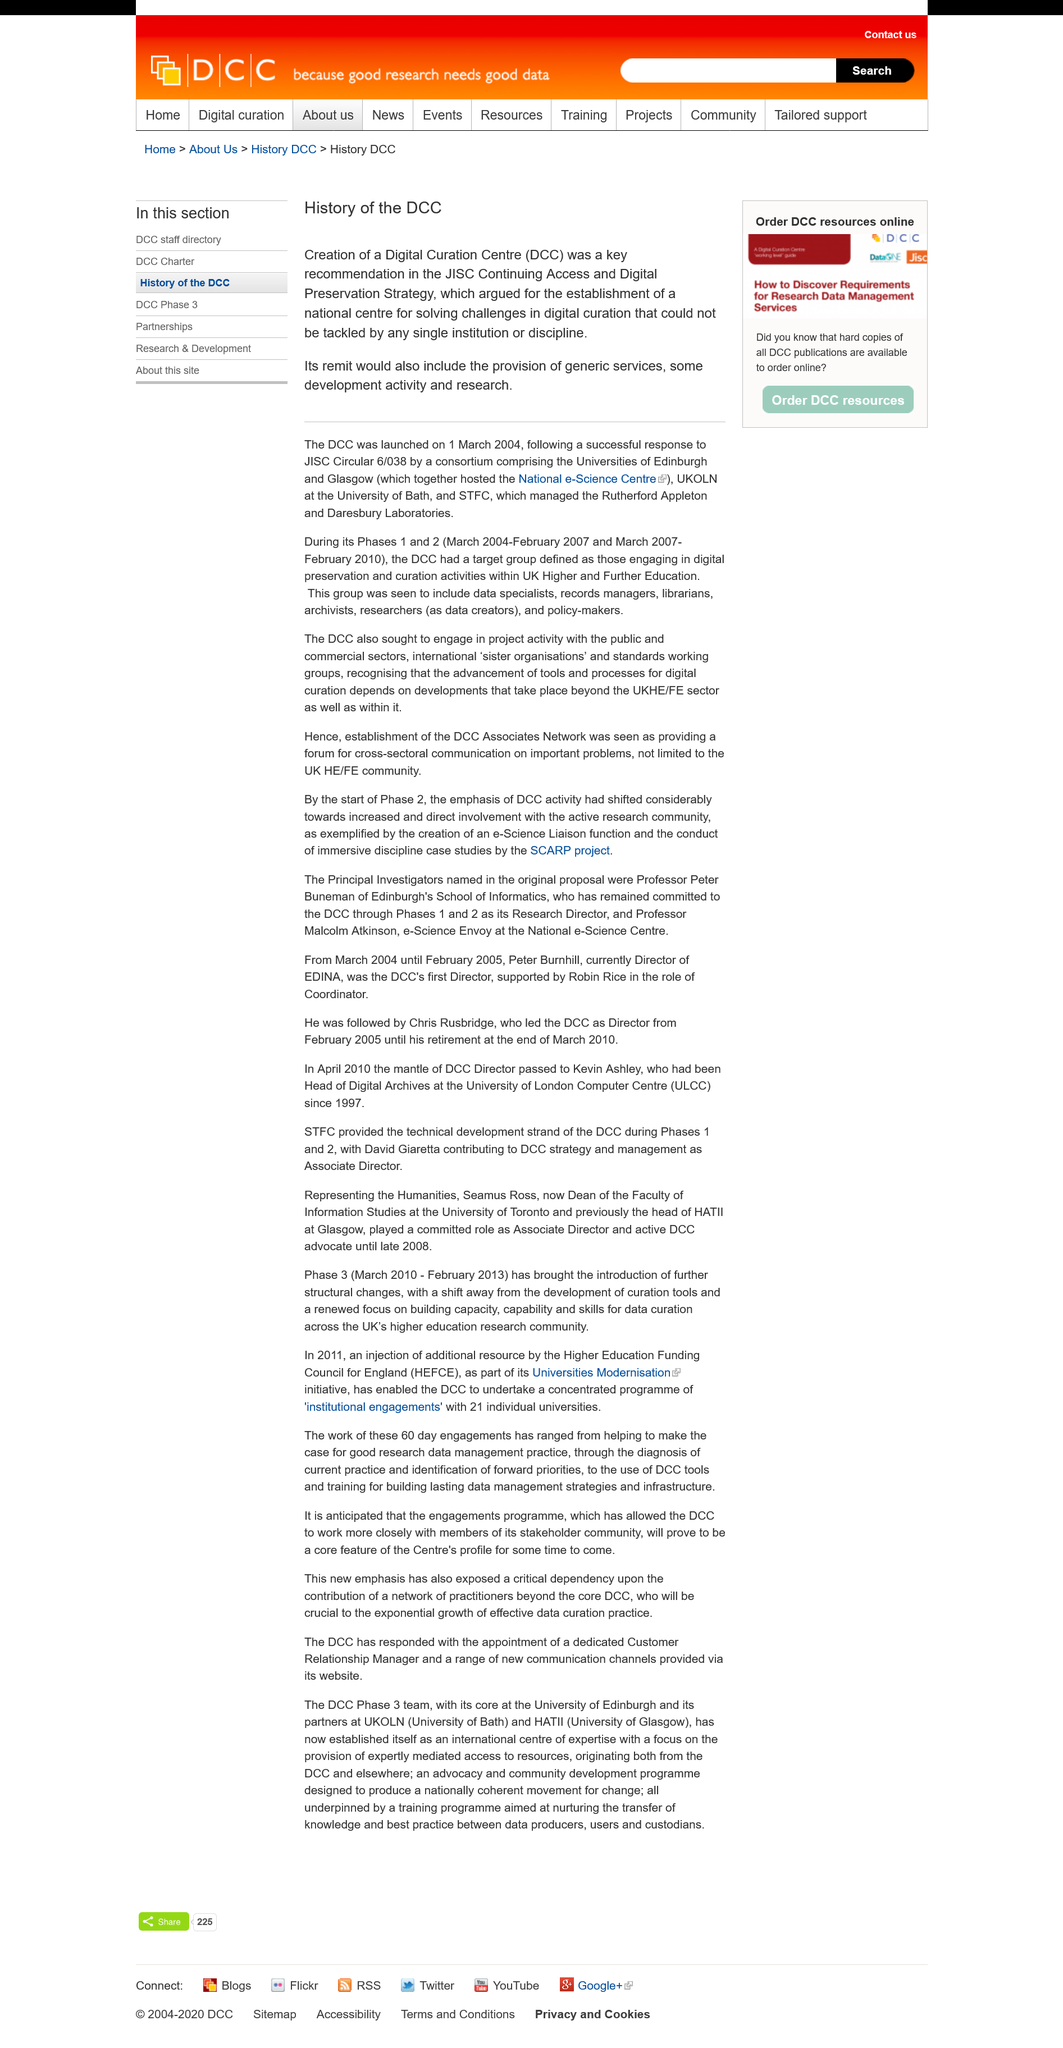Mention a couple of crucial points in this snapshot. The Rutherford Appleton and Daresbury Laboratories were managed by the Science and Technology Facilities Council (STFC). The Digital Currency Commerce (DCC) was launched on March 1, 2004. The fact that the Data Communications Company (DCC) was a key recommendation in the JISC Continuing Access and Digital Preservation Strategy is a part of the history of the DCC. 